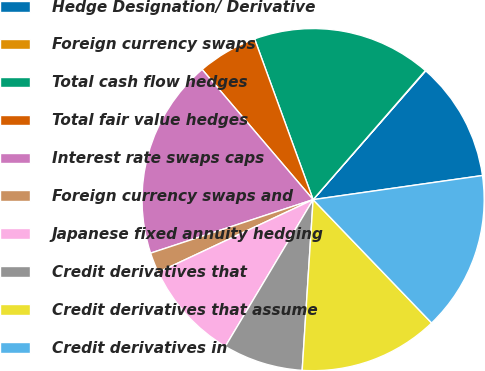<chart> <loc_0><loc_0><loc_500><loc_500><pie_chart><fcel>Hedge Designation/ Derivative<fcel>Foreign currency swaps<fcel>Total cash flow hedges<fcel>Total fair value hedges<fcel>Interest rate swaps caps<fcel>Foreign currency swaps and<fcel>Japanese fixed annuity hedging<fcel>Credit derivatives that<fcel>Credit derivatives that assume<fcel>Credit derivatives in<nl><fcel>11.32%<fcel>0.04%<fcel>16.95%<fcel>5.68%<fcel>18.83%<fcel>1.92%<fcel>9.44%<fcel>7.56%<fcel>13.2%<fcel>15.07%<nl></chart> 